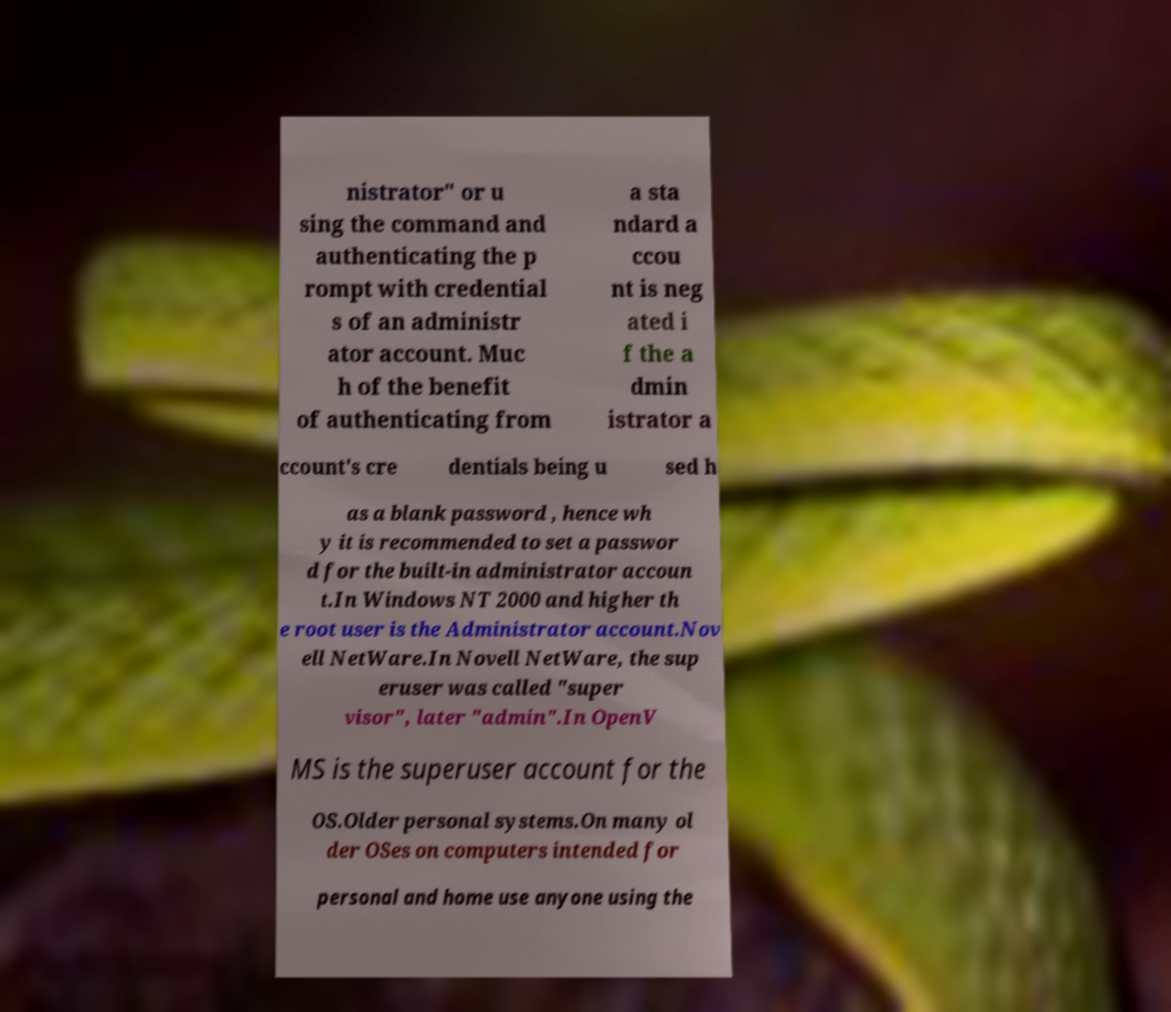Can you accurately transcribe the text from the provided image for me? nistrator" or u sing the command and authenticating the p rompt with credential s of an administr ator account. Muc h of the benefit of authenticating from a sta ndard a ccou nt is neg ated i f the a dmin istrator a ccount's cre dentials being u sed h as a blank password , hence wh y it is recommended to set a passwor d for the built-in administrator accoun t.In Windows NT 2000 and higher th e root user is the Administrator account.Nov ell NetWare.In Novell NetWare, the sup eruser was called "super visor", later "admin".In OpenV MS is the superuser account for the OS.Older personal systems.On many ol der OSes on computers intended for personal and home use anyone using the 